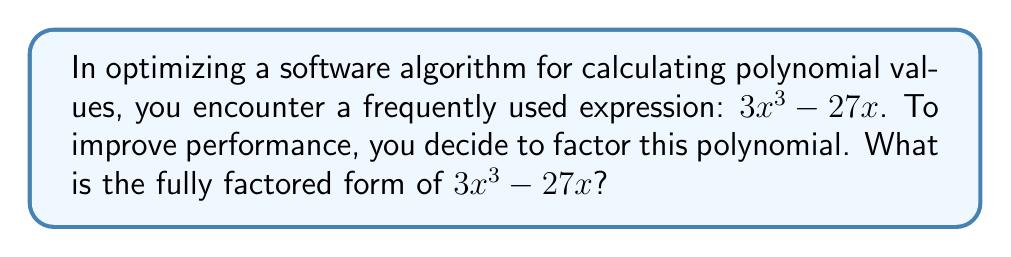Give your solution to this math problem. Let's approach this step-by-step:

1) First, we can factor out the greatest common factor (GCF):
   $3x^3 - 27x = 3x(x^2 - 9)$

2) Now, we focus on the factor $(x^2 - 9)$. This is a difference of squares, which can be factored as $(a+b)(a-b)$ where $a^2$ is the first term and $b^2$ is the second term.

3) For $x^2 - 9$:
   $a^2 = x^2$, so $a = x$
   $b^2 = 9$, so $b = 3$

4) Therefore, $x^2 - 9 = (x+3)(x-3)$

5) Putting it all together:
   $3x^3 - 27x = 3x(x^2 - 9) = 3x(x+3)(x-3)$

This factored form allows for more efficient computation in software, as it reduces the number of multiplications needed to evaluate the polynomial for any given x.
Answer: $3x(x+3)(x-3)$ 